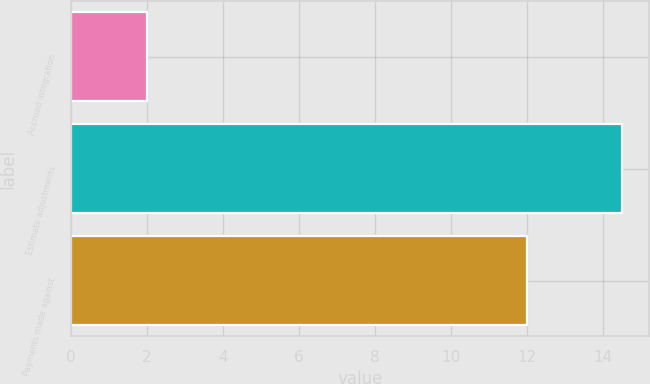Convert chart. <chart><loc_0><loc_0><loc_500><loc_500><bar_chart><fcel>Accrued integration<fcel>Estimate adjustments<fcel>Payments made against<nl><fcel>2<fcel>14.5<fcel>12<nl></chart> 